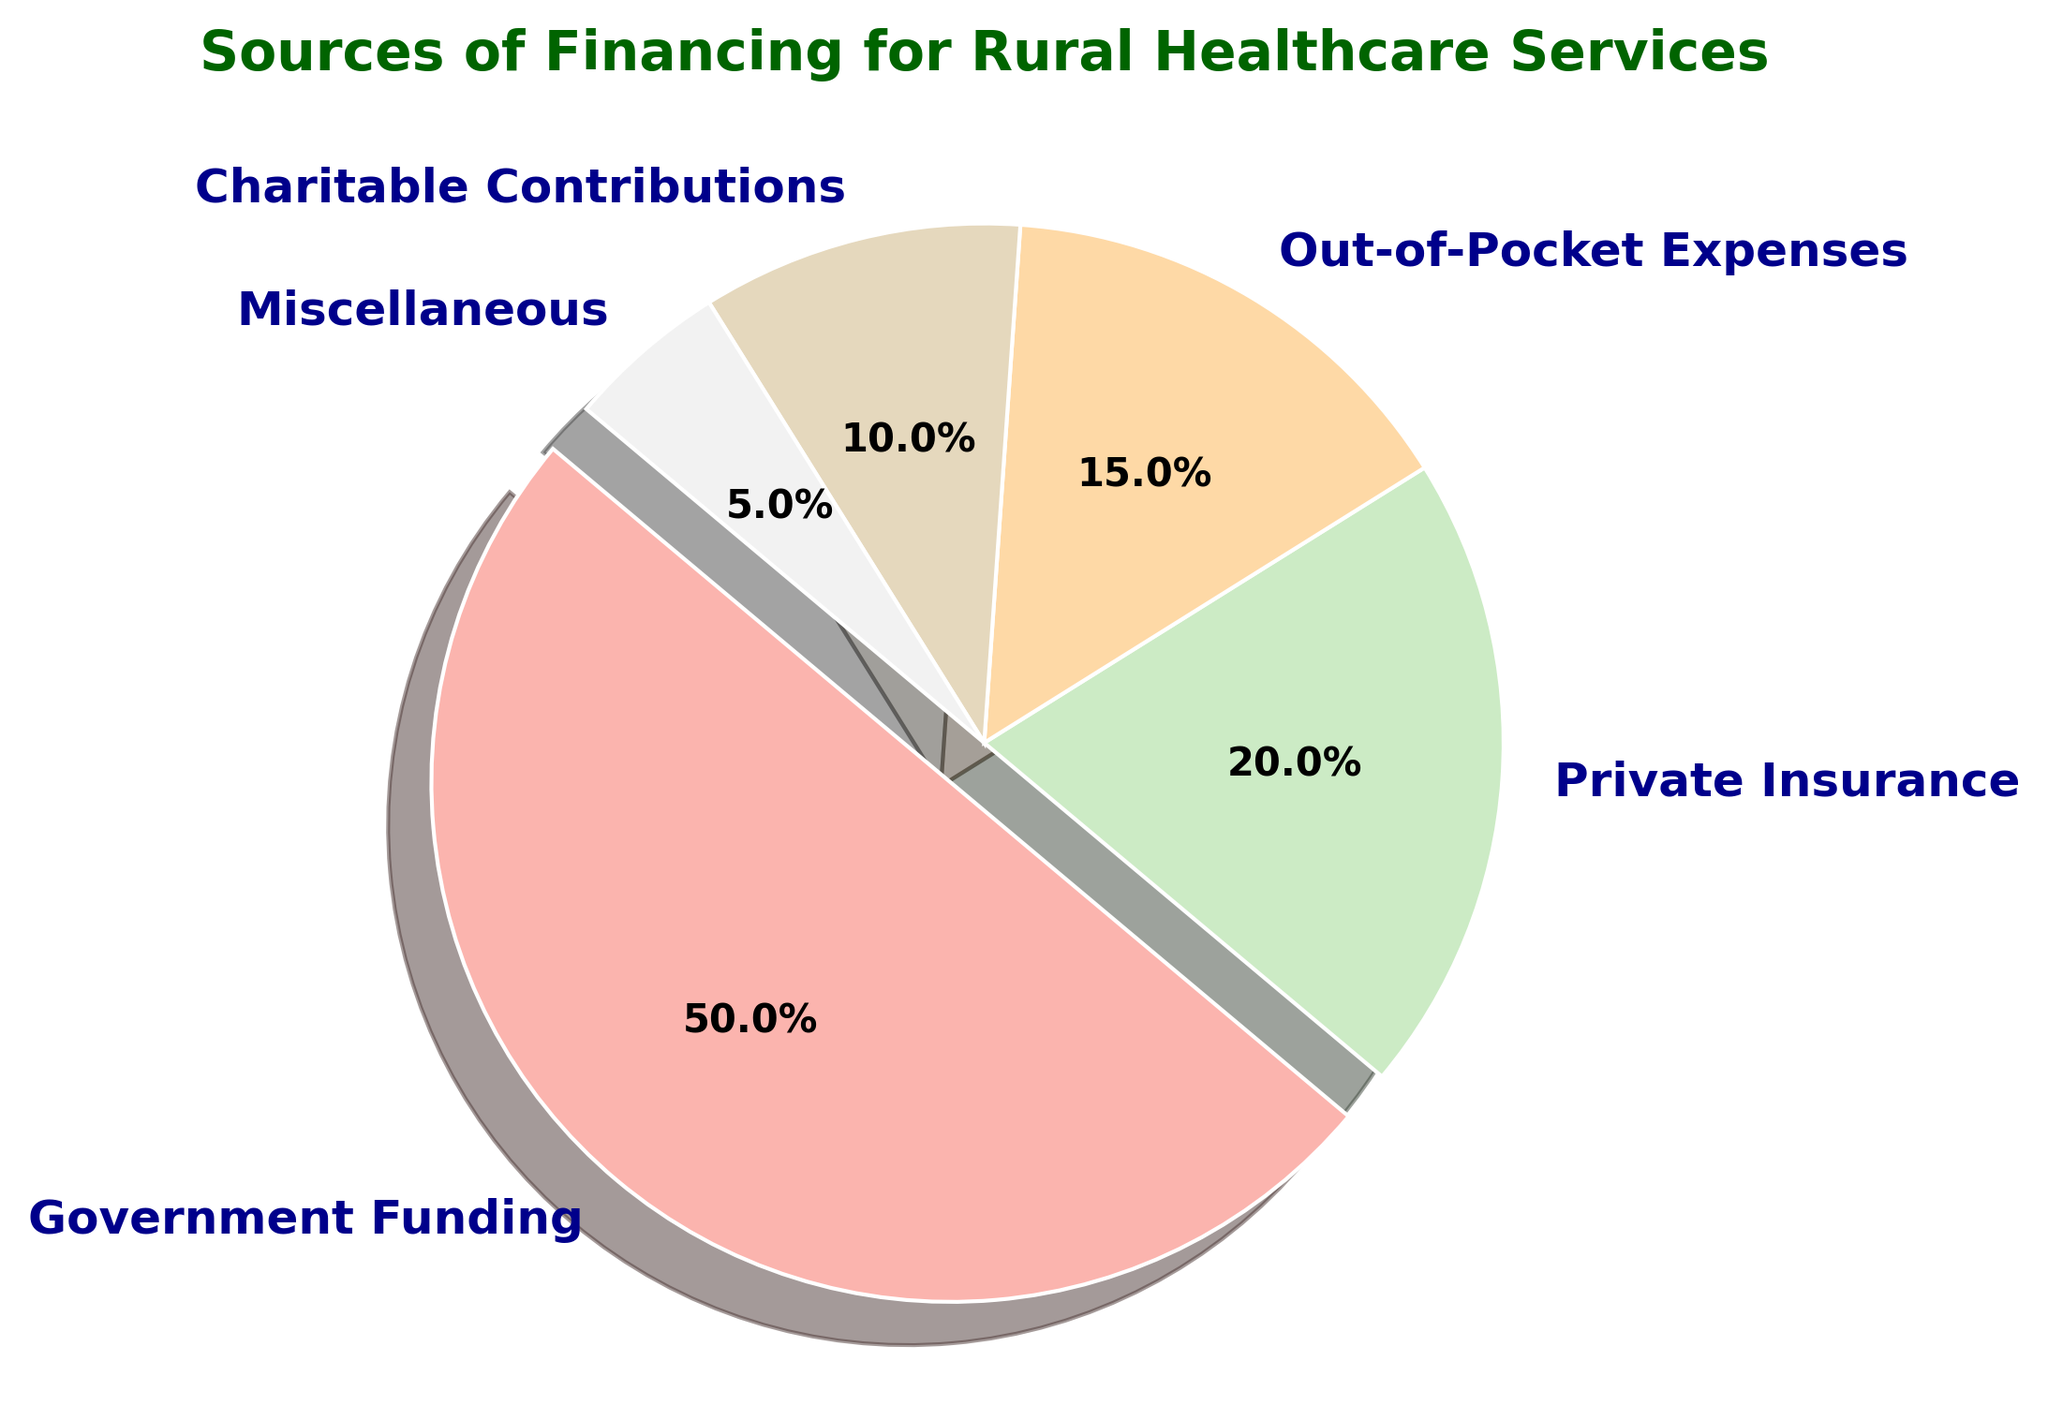Which category has the highest percentage of financing? By examining the pie chart, we see that the category with the largest section is Government Funding. This is also visually highlighted by an exploded wedge in the pie chart.
Answer: Government Funding What percentage of financing is covered by both Out-of-Pocket Expenses and Charitable Contributions combined? To find the combined percentage, add the values for Out-of-Pocket Expenses (15%) and Charitable Contributions (10%). 15 + 10 = 25%.
Answer: 25% How much larger is the percentage of Government Funding compared to Private Insurance? Subtract the percentage of Private Insurance (20%) from the percentage of Government Funding (50%). 50 - 20 = 30%.
Answer: 30% Which two categories together contribute to 30% of the financing? Add the percentages for each pair of categories until you find that Private Insurance (20%) and Miscellaneous (5%) together with Charitable Contributions (10%) form the sum of 30%. 20 + 10 = 30 and 15+15 = 30, so the categories are Private Insurance and Charitable Contributions.
Answer: Private Insurance and Charitable Contributions What is the second-largest category represented in the pie chart? The second-largest section in the pie chart, after Government Funding (50%), is Private Insurance.
Answer: Private Insurance What visual attribute highlights the largest category in the pie chart? The largest category, Government Funding, is visually highlighted by having an exploded wedge, making it stand out from the rest.
Answer: Exploded Wedge By how much does the percentage of Out-of-Pocket Expenses exceed Miscellaneous? Subtract the percentage of Miscellaneous (5%) from the percentage of Out-of-Pocket Expenses (15%). 15 - 5 = 10%.
Answer: 10% How does the percentage of Charitable Contributions compare to the percentage of Miscellaneous? The percentage of Charitable Contributions (10%) is double that of Miscellaneous (5%).
Answer: Double 